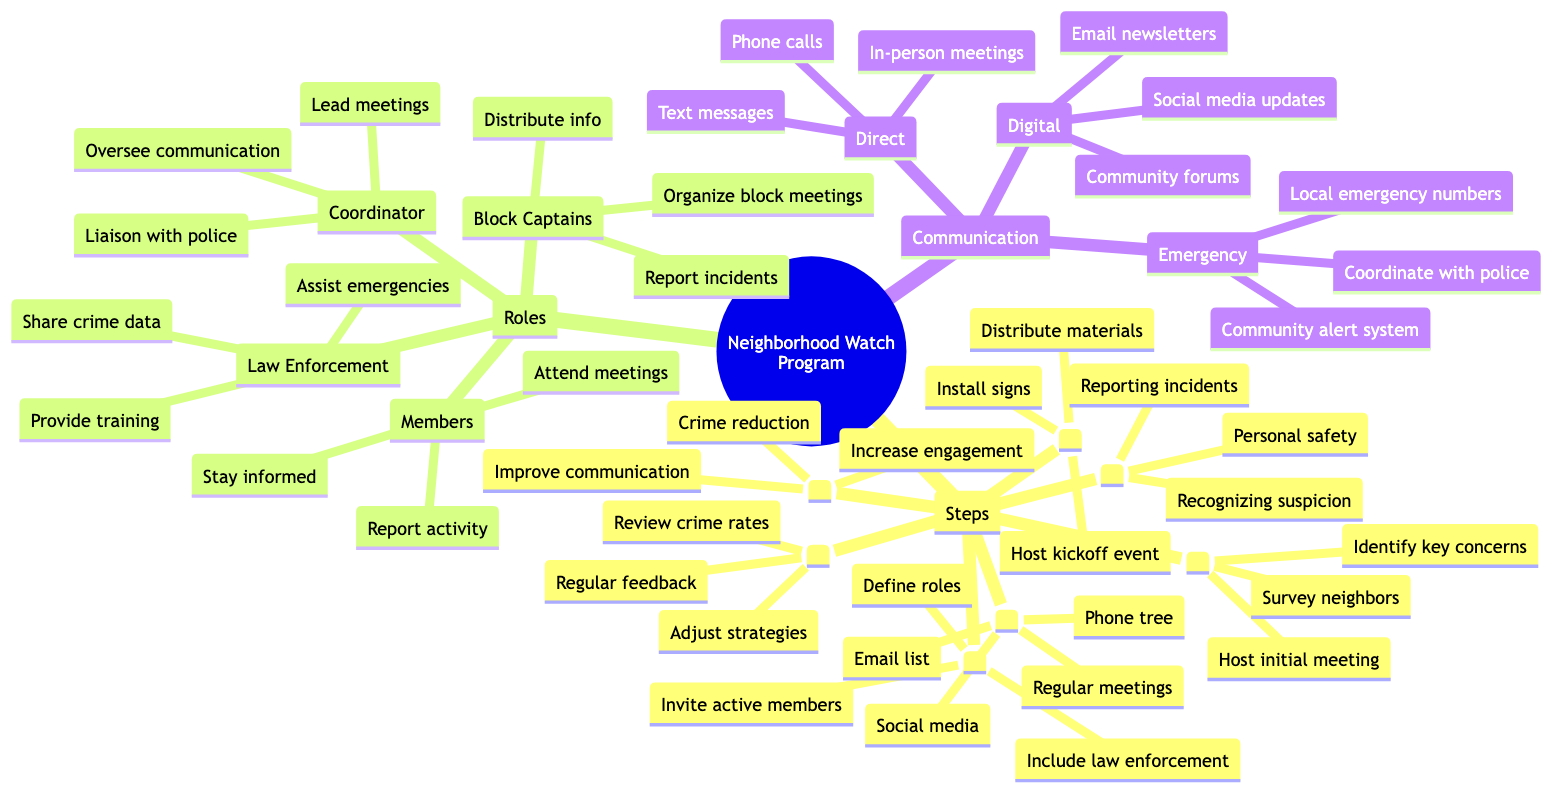What is the first step in developing a Neighborhood Watch Program? The diagram clearly indicates "1. Assess Community Interest" as the first step listed under the "Steps" category. This shows that determining the community's interest is the initial action taken.
Answer: Assess Community Interest How many roles are listed in the Roles section? The diagram specifies four distinct roles under the "Roles" category: Coordinator, Block Captains, Members, and Local Law Enforcement, which totals to four roles.
Answer: 4 What is one of the communication channels listed under Direct communication? The diagram lists multiple options under the "Direct" communication category, including "Phone calls," which is one of the specific examples provided.
Answer: Phone calls Which step focuses on community training? Within the "Steps" section, the fifth step is titled "5. Organize Community Training," making it the specific step addressing this focus.
Answer: Organize Community Training What is the primary goal established in the Goals and Objectives section? The diagram includes three specific goals; among them is "Crime reduction," explicitly highlighted as a key objective for the program.
Answer: Crime reduction What do Block Captains do according to their role description? The diagram outlines several responsibilities for Block Captains, including "Organize block-level meetings," clarifying their role in community organization and leadership.
Answer: Organize block-level meetings How many different types of communication channels are listed? According to the "Communication Channels" section, there are three distinctly categorized types: Direct, Digital, and Emergency, leading to a total of three types of communication channels.
Answer: 3 What should be done during the program launch? During the launch phase, one of the actions specified is "Host a kickoff event," which serves as a critical activity during this program launch step.
Answer: Host a kickoff event What is one type of digital communication mentioned? In the "Digital" communication category, "Email newsletters" is explicitly listed as an example of the communication methods utilized for community updates or information sharing.
Answer: Email newsletters 